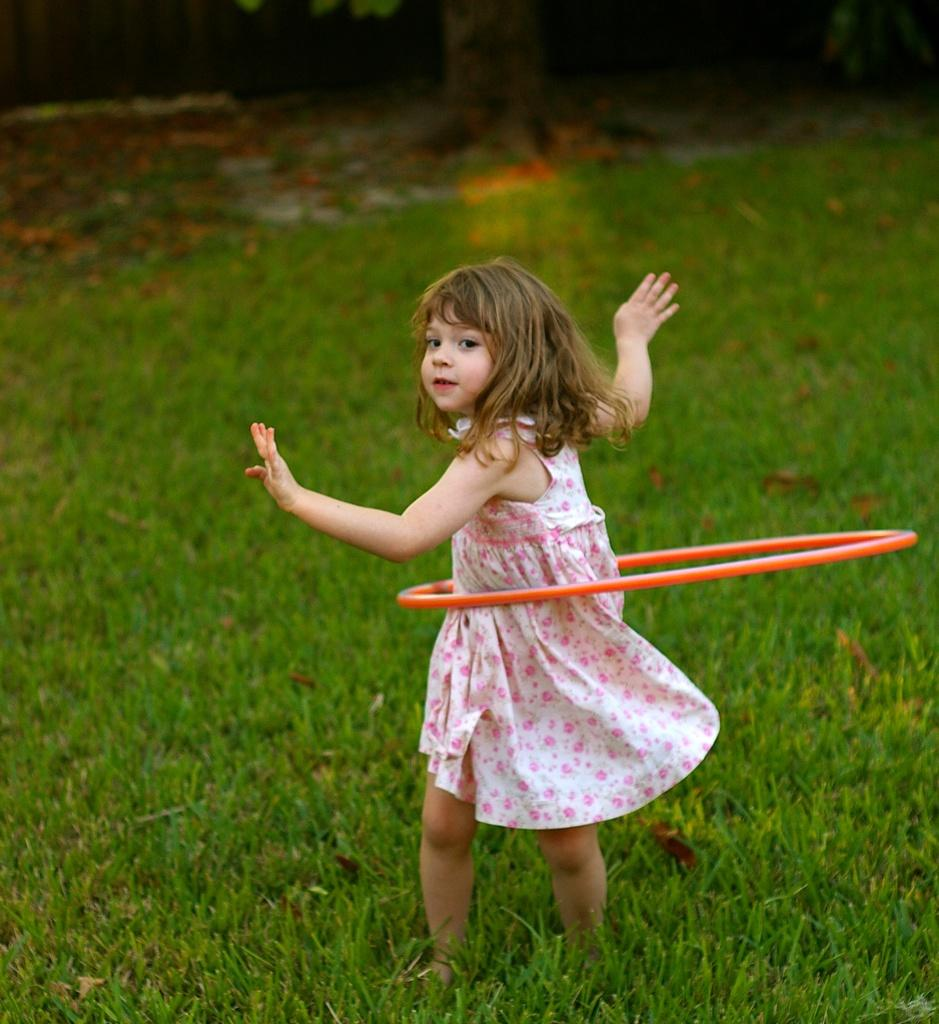What is the main subject of the image? The main subject of the image is a kid. What is the kid doing in the image? The kid is standing and playing with a ring. What type of surface is visible at the bottom of the image? There is grass at the bottom of the image. How would you describe the background of the image? The background of the image is blurry. What does the caption on the image say? There is no caption present in the image. Is the kid's father visible in the image? There is no indication of the kid's father being present in the image. What type of umbrella is being used by the kid in the image? There is no umbrella present in the image. 